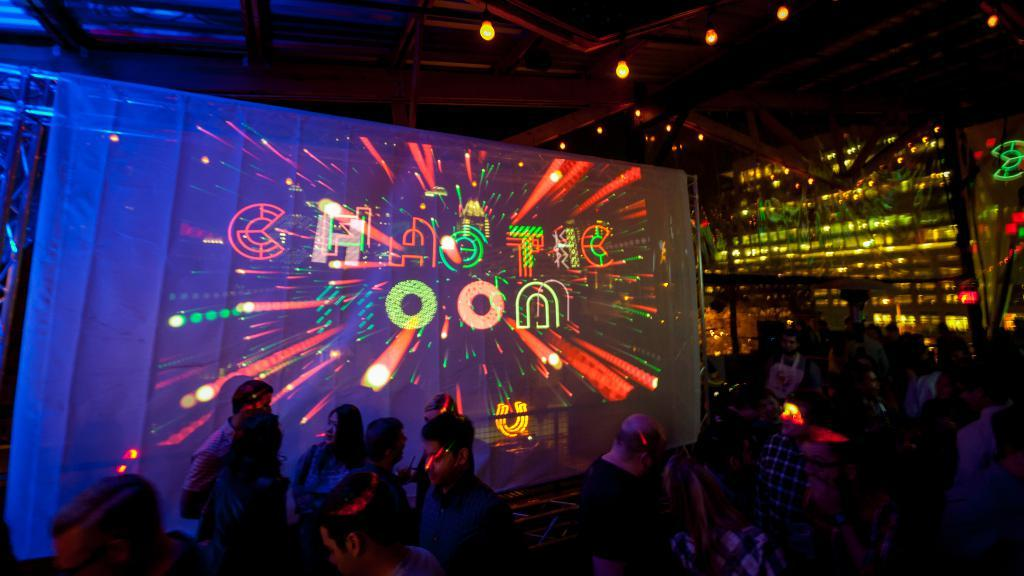<image>
Summarize the visual content of the image. A neon sign spells out the word Chaotic in a darkened night club full of people. 